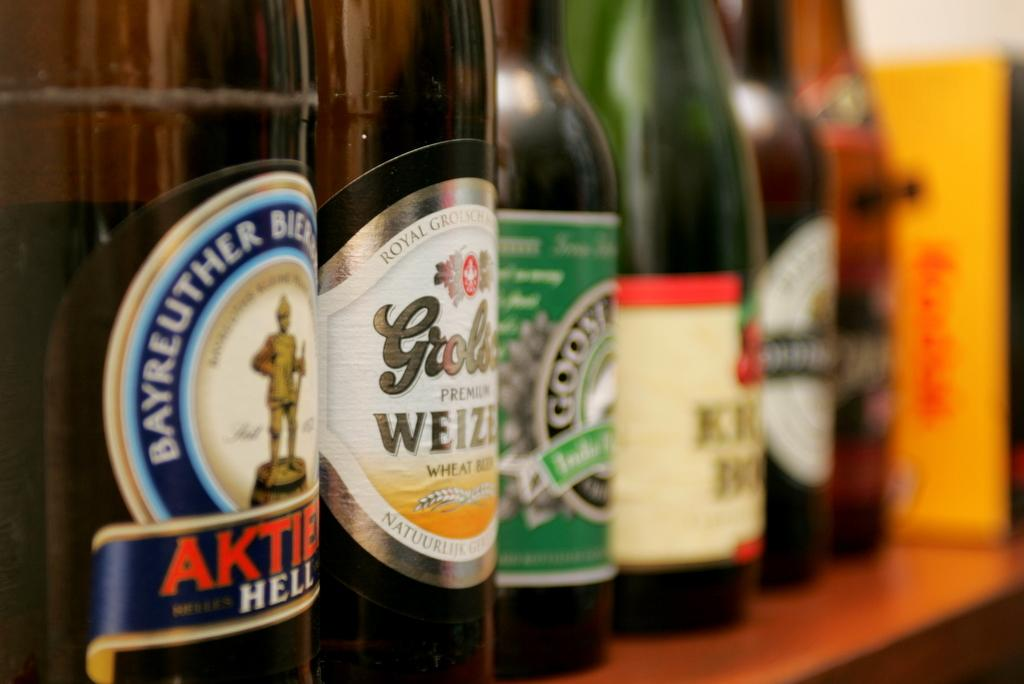Provide a one-sentence caption for the provided image. Several labeled drink bottles lined up, including Bayreuther. 